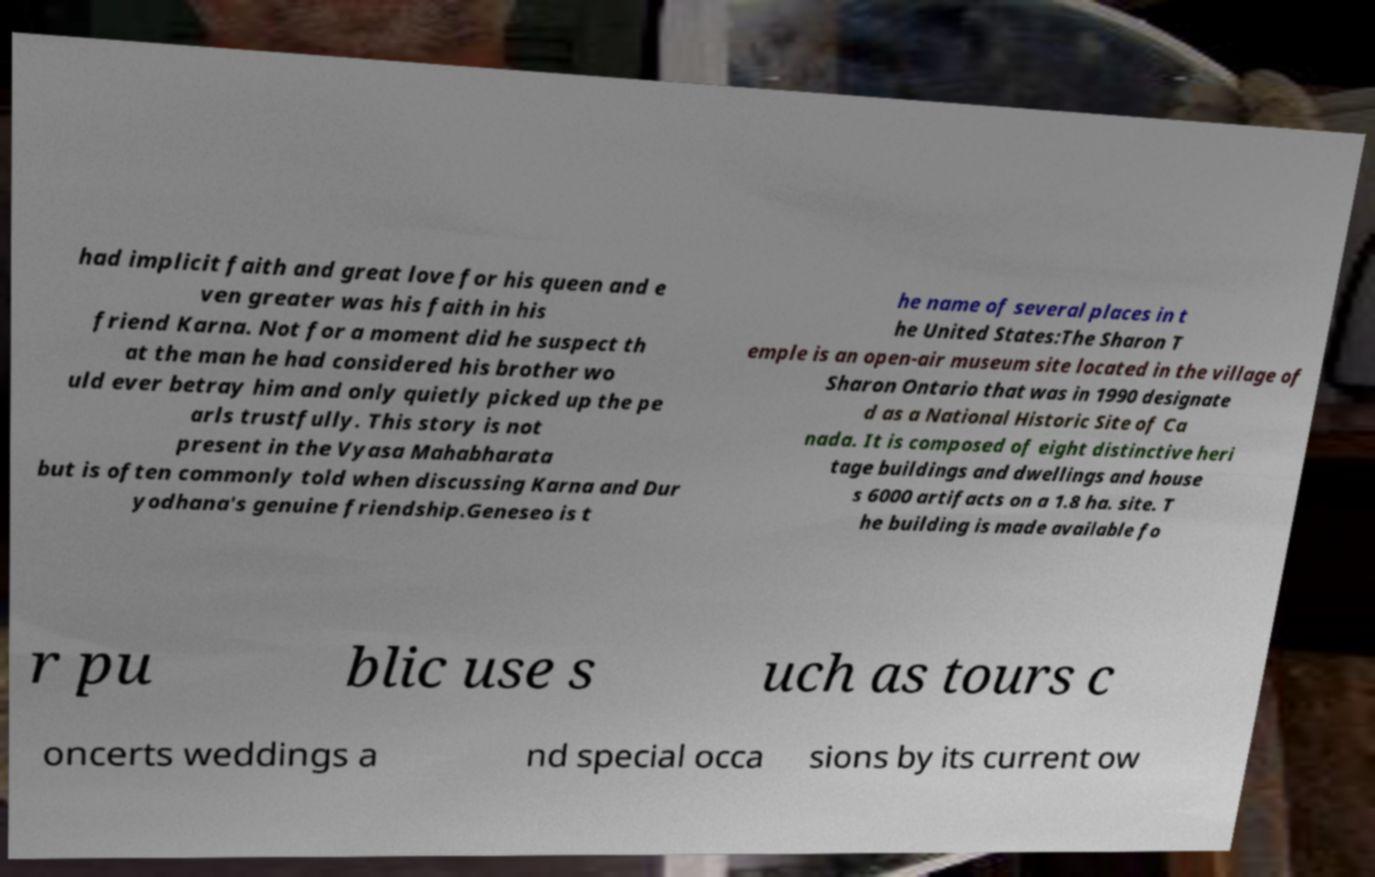Can you accurately transcribe the text from the provided image for me? had implicit faith and great love for his queen and e ven greater was his faith in his friend Karna. Not for a moment did he suspect th at the man he had considered his brother wo uld ever betray him and only quietly picked up the pe arls trustfully. This story is not present in the Vyasa Mahabharata but is often commonly told when discussing Karna and Dur yodhana's genuine friendship.Geneseo is t he name of several places in t he United States:The Sharon T emple is an open-air museum site located in the village of Sharon Ontario that was in 1990 designate d as a National Historic Site of Ca nada. It is composed of eight distinctive heri tage buildings and dwellings and house s 6000 artifacts on a 1.8 ha. site. T he building is made available fo r pu blic use s uch as tours c oncerts weddings a nd special occa sions by its current ow 